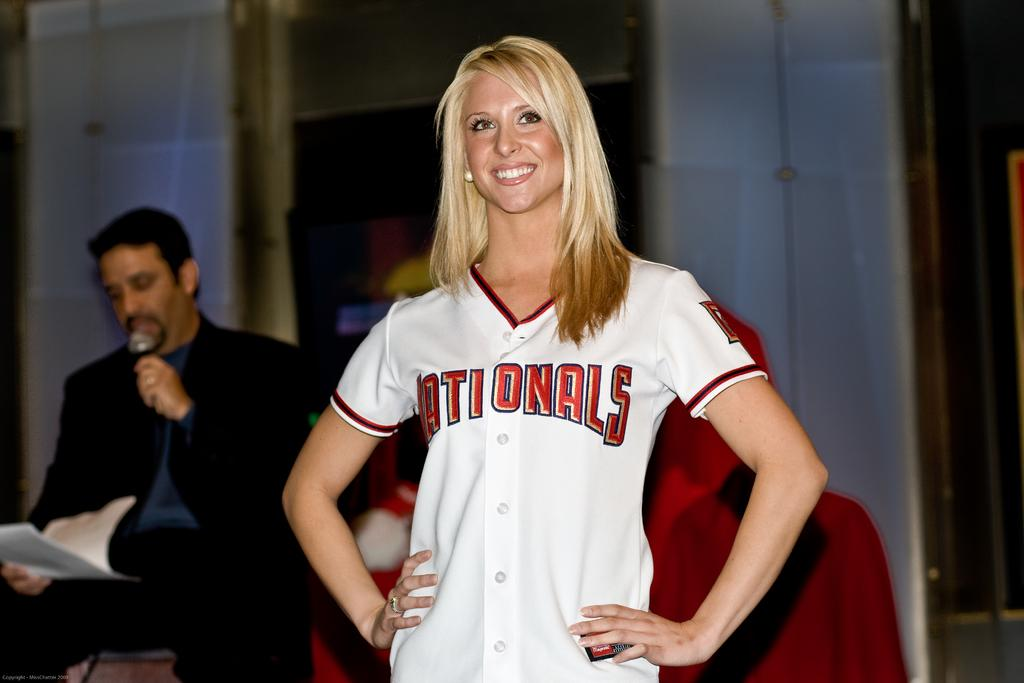How many people are in the image? There are two people in the image, one standing and one sitting. What is the standing person wearing? The standing person is wearing a white t-shirt. What is the sitting person holding? The sitting person is holding a microphone and papers in his hand. What is the sitting person's attire? The sitting person is wearing a suit. Can you see a plane flying in the background of the image? No, there is no plane visible in the image. Is there a yak present in the image? No, there is no yak present in the image. 